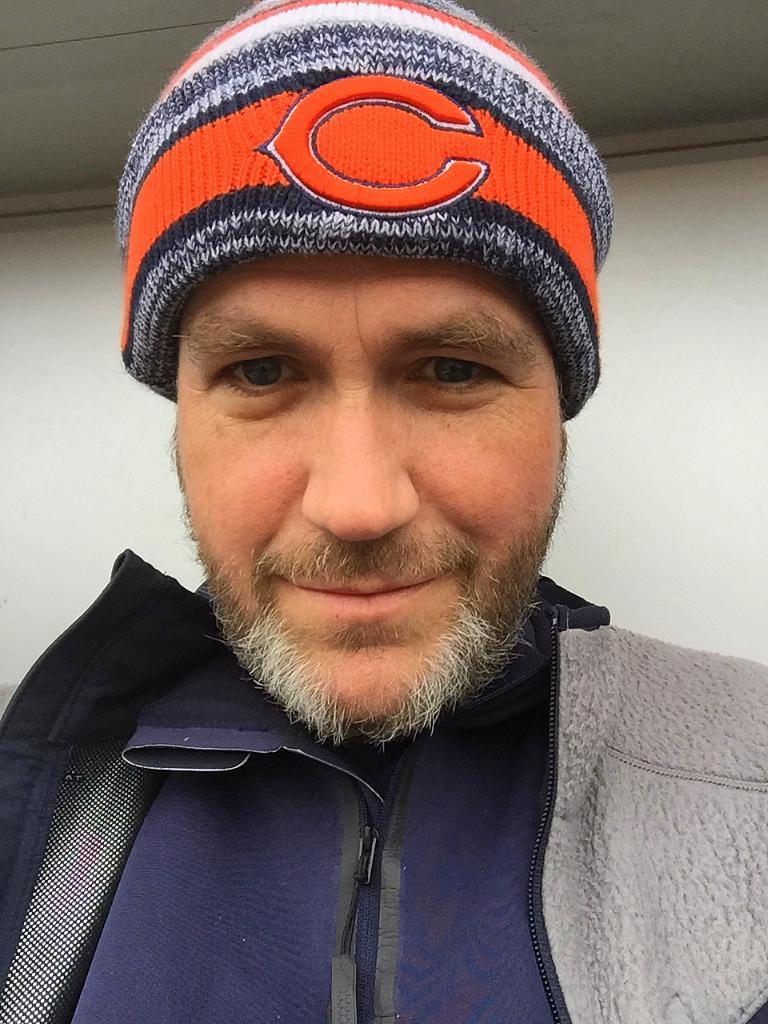What is the main subject of the picture? The main subject of the picture is a man. What is the man wearing on his head? The man is wearing a cap on his head. What can be seen in the background of the picture? There is a wall in the background of the picture. What type of pie is the man holding in the picture? There is no pie present in the image; the man is not holding anything. 